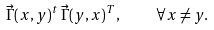<formula> <loc_0><loc_0><loc_500><loc_500>\vec { \Gamma } ( x , y ) ^ { t } \, \vec { \Gamma } ( y , x ) ^ { T } , \quad \forall x \neq y .</formula> 